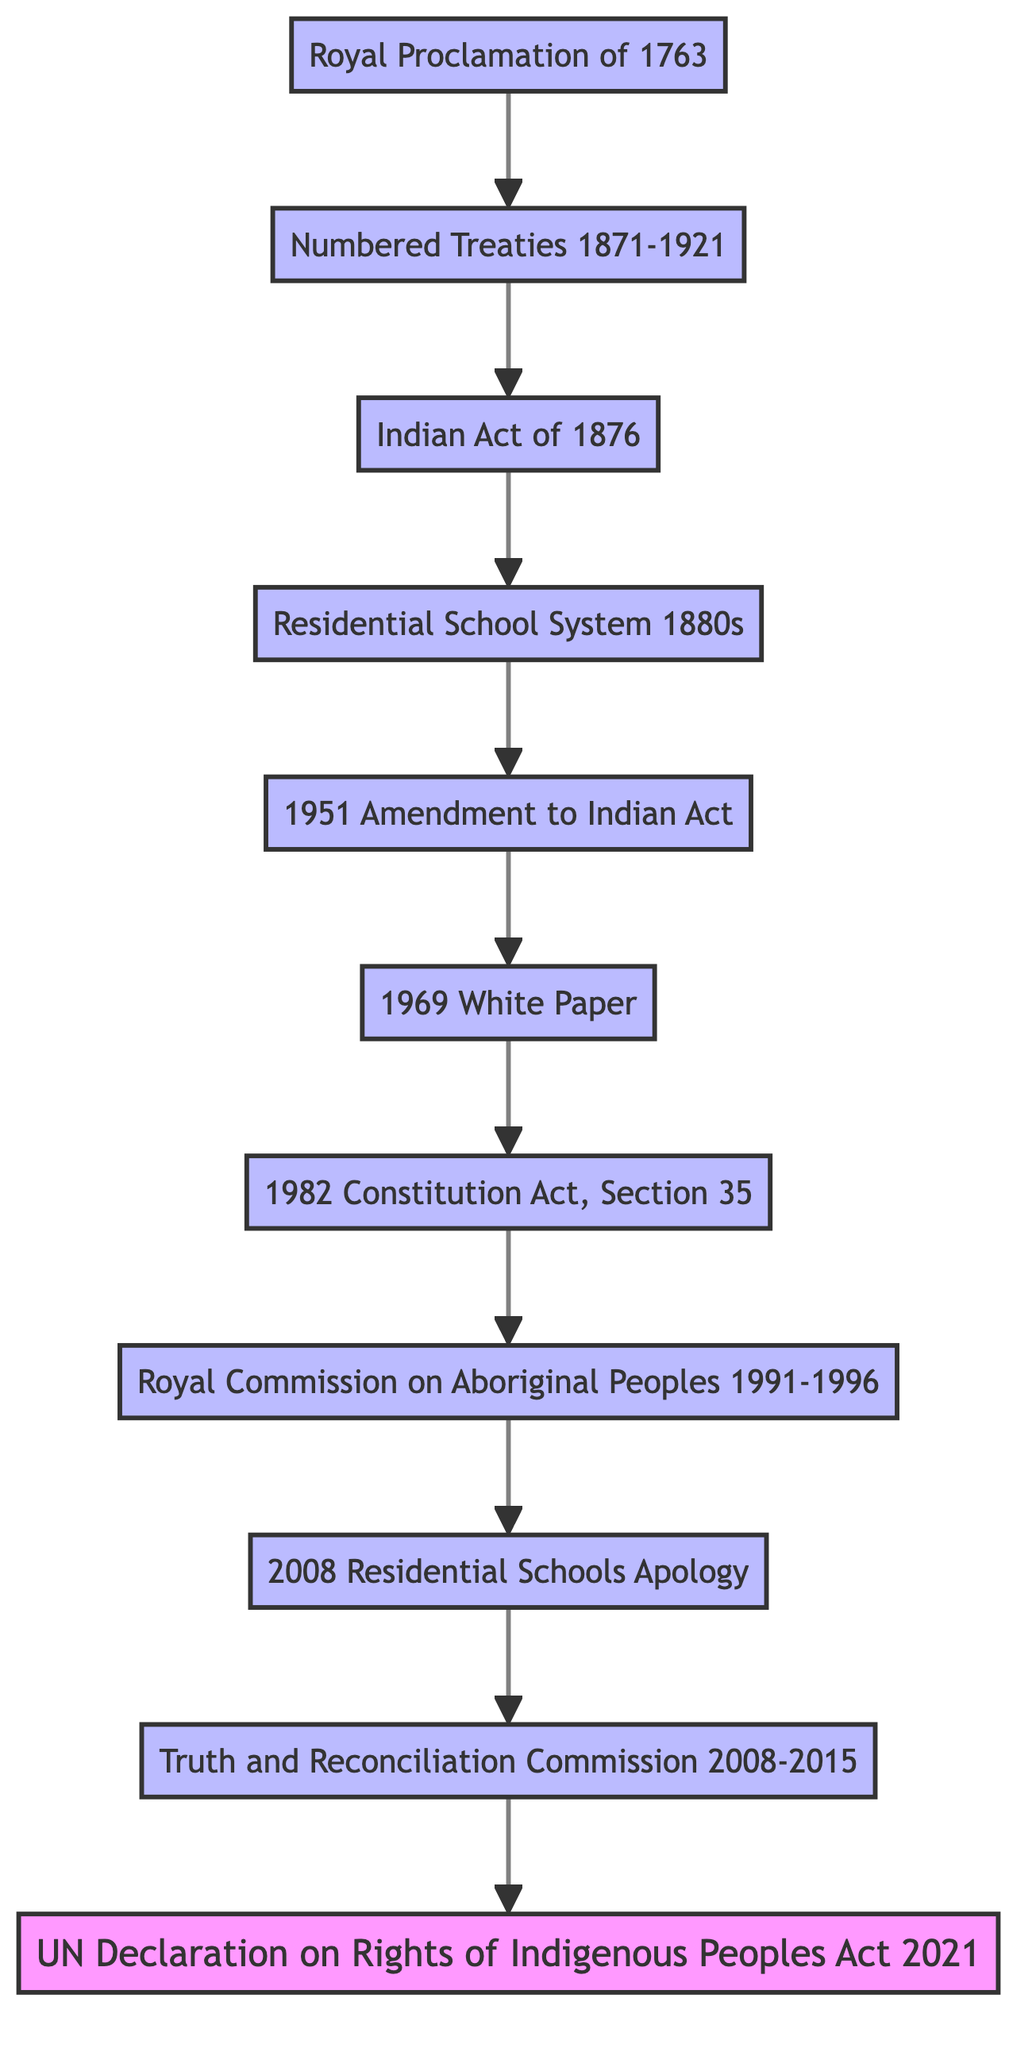What is the starting point of the flowchart? The diagram opens with the "Royal Proclamation of 1763" as the first element, which indicates where the progression begins.
Answer: Royal Proclamation of 1763 How many key milestones are represented in the flowchart? There are a total of 11 distinct elements listed in the flowchart, which trace the progression of Indigenous rights in Canada.
Answer: 11 Which milestone directly follows the Indian Act of 1876? The flowchart shows that the milestone right after the Indian Act of 1876 is the "Residential School System established in the 1880s."
Answer: Residential School System (established in 1880s) What event is connected to the 1969 White Paper? Following the 1969 White Paper in the diagram, the next milestone is the "1982 Constitution Act, Section 35," which relates to the recognition of rights.
Answer: 1982 Constitution Act, Section 35 What significant action was taken in 2008 regarding residential schools? The diagram indicates that in 2008, there was a "Residential Schools Apology," marking a formal acknowledgment of past wrongs linked to the residential school system.
Answer: 2008 Residential Schools Apology What milestone links the Royal Commission on Aboriginal Peoples to the Truth and Reconciliation Commission? The diagram shows a direct connection from the "Royal Commission on Aboriginal Peoples (1991-1996)" to the "Truth and Reconciliation Commission (2008-2015)," indicating a sequential inquiry into Indigenous issues.
Answer: Truth and Reconciliation Commission (2008-2015) What is the most recent milestone in the flowchart? The last element at the top of the flowchart is the "UN Declaration on the Rights of Indigenous Peoples Act (2021)," indicating the most recent legislative action regarding Indigenous rights.
Answer: UN Declaration on the Rights of Indigenous Peoples Act (2021) Which event leads to the recognition and affirmation of Aboriginal and treaty rights? The flowchart illustrates that the "1982 Constitution Act, Section 35" follows the "1969 White Paper," leading to the recognition of Aboriginal and treaty rights in Canada.
Answer: 1982 Constitution Act, Section 35 In what year did the Numbered Treaties occur? The flowchart pinpoints the timeline for the Numbered Treaties, which spanned from 1871 to 1921, connecting to various agreements between the Canadian government and Indigenous nations.
Answer: 1871-1921 